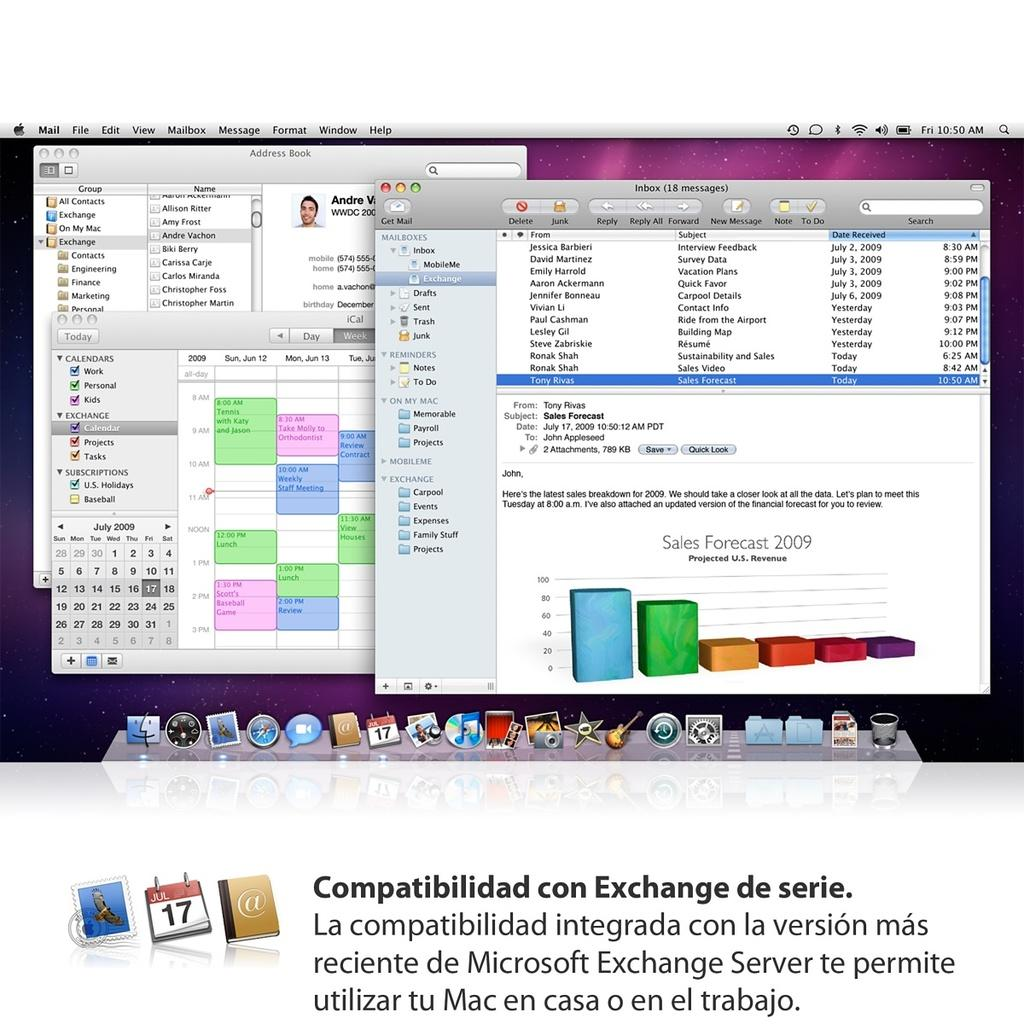<image>
Render a clear and concise summary of the photo. computer screen is displayed to compatibilidad con  exchange 